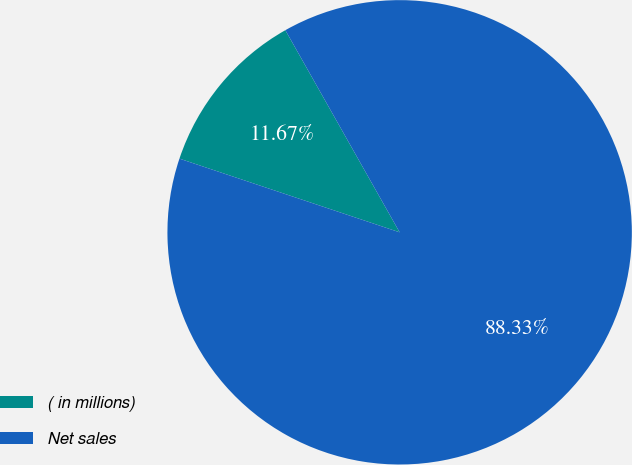Convert chart to OTSL. <chart><loc_0><loc_0><loc_500><loc_500><pie_chart><fcel>( in millions)<fcel>Net sales<nl><fcel>11.67%<fcel>88.33%<nl></chart> 